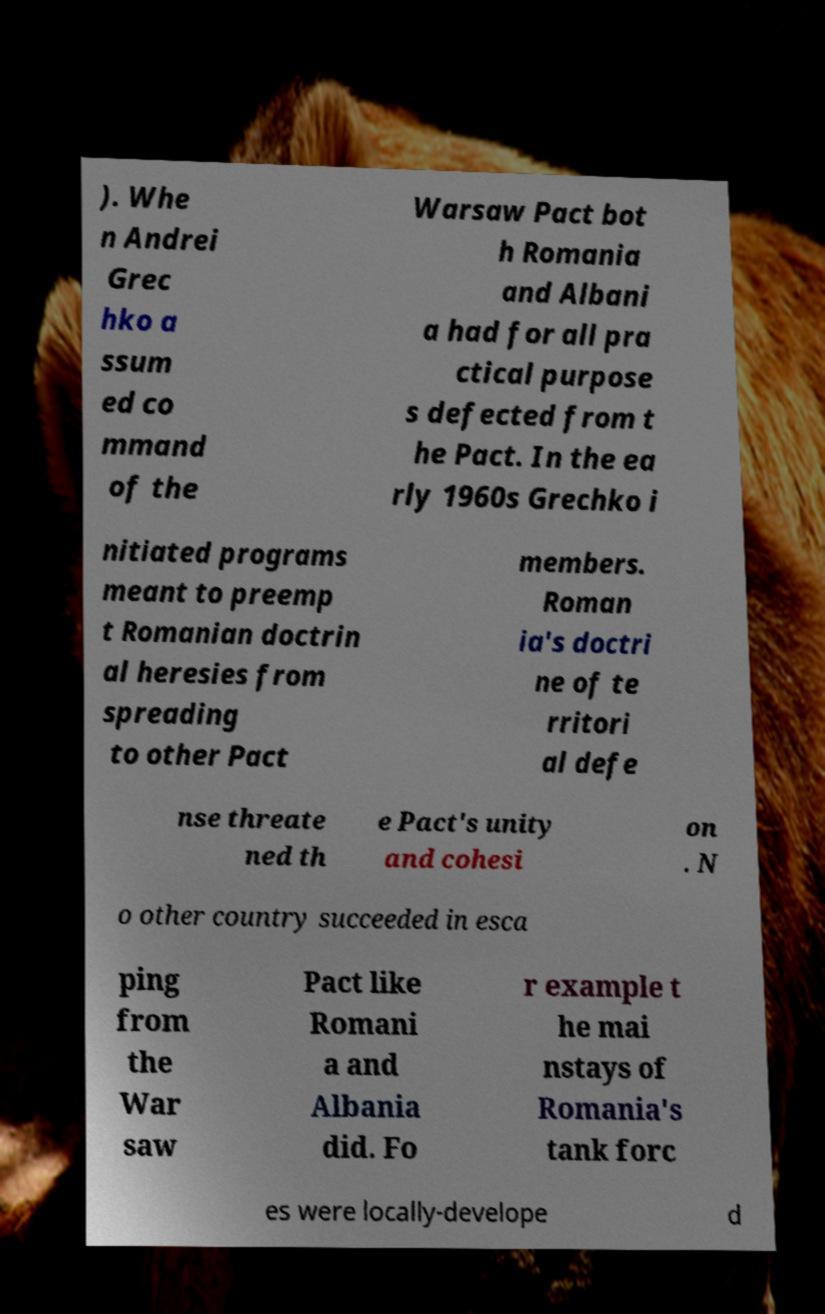Could you extract and type out the text from this image? ). Whe n Andrei Grec hko a ssum ed co mmand of the Warsaw Pact bot h Romania and Albani a had for all pra ctical purpose s defected from t he Pact. In the ea rly 1960s Grechko i nitiated programs meant to preemp t Romanian doctrin al heresies from spreading to other Pact members. Roman ia's doctri ne of te rritori al defe nse threate ned th e Pact's unity and cohesi on . N o other country succeeded in esca ping from the War saw Pact like Romani a and Albania did. Fo r example t he mai nstays of Romania's tank forc es were locally-develope d 